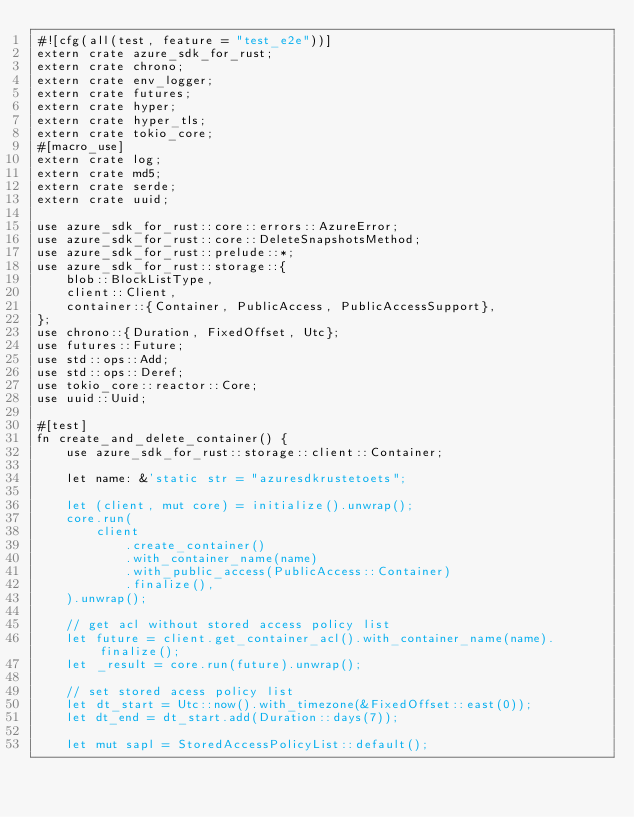Convert code to text. <code><loc_0><loc_0><loc_500><loc_500><_Rust_>#![cfg(all(test, feature = "test_e2e"))]
extern crate azure_sdk_for_rust;
extern crate chrono;
extern crate env_logger;
extern crate futures;
extern crate hyper;
extern crate hyper_tls;
extern crate tokio_core;
#[macro_use]
extern crate log;
extern crate md5;
extern crate serde;
extern crate uuid;

use azure_sdk_for_rust::core::errors::AzureError;
use azure_sdk_for_rust::core::DeleteSnapshotsMethod;
use azure_sdk_for_rust::prelude::*;
use azure_sdk_for_rust::storage::{
    blob::BlockListType,
    client::Client,
    container::{Container, PublicAccess, PublicAccessSupport},
};
use chrono::{Duration, FixedOffset, Utc};
use futures::Future;
use std::ops::Add;
use std::ops::Deref;
use tokio_core::reactor::Core;
use uuid::Uuid;

#[test]
fn create_and_delete_container() {
    use azure_sdk_for_rust::storage::client::Container;

    let name: &'static str = "azuresdkrustetoets";

    let (client, mut core) = initialize().unwrap();
    core.run(
        client
            .create_container()
            .with_container_name(name)
            .with_public_access(PublicAccess::Container)
            .finalize(),
    ).unwrap();

    // get acl without stored access policy list
    let future = client.get_container_acl().with_container_name(name).finalize();
    let _result = core.run(future).unwrap();

    // set stored acess policy list
    let dt_start = Utc::now().with_timezone(&FixedOffset::east(0));
    let dt_end = dt_start.add(Duration::days(7));

    let mut sapl = StoredAccessPolicyList::default();</code> 